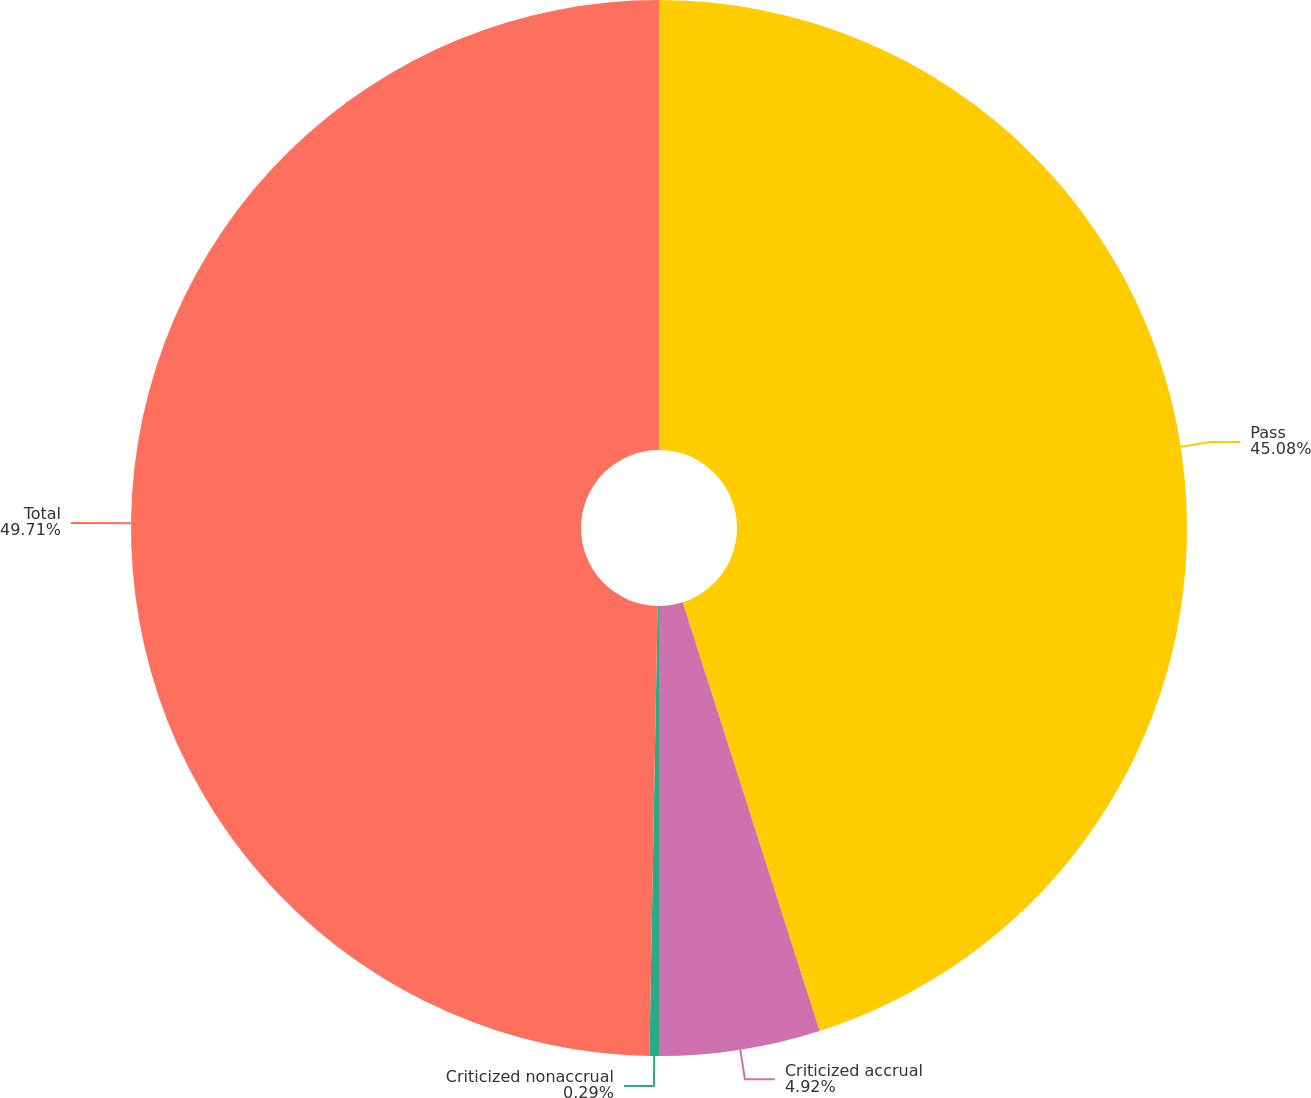Convert chart. <chart><loc_0><loc_0><loc_500><loc_500><pie_chart><fcel>Pass<fcel>Criticized accrual<fcel>Criticized nonaccrual<fcel>Total<nl><fcel>45.08%<fcel>4.92%<fcel>0.29%<fcel>49.71%<nl></chart> 